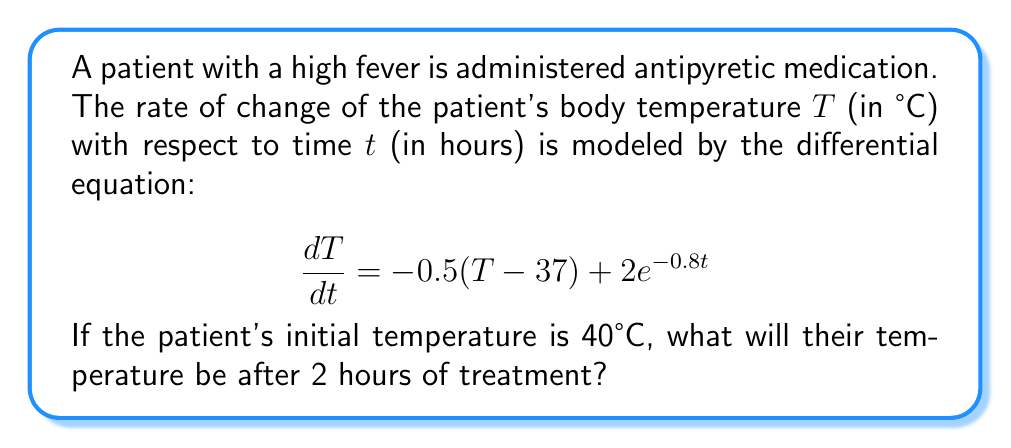Can you solve this math problem? To solve this problem, we need to use the given first-order differential equation and initial condition:

1) The differential equation is:
   $$\frac{dT}{dt} = -0.5(T - 37) + 2e^{-0.8t}$$

2) The initial condition is:
   $T(0) = 40°C$

3) This is a linear first-order differential equation. We can solve it using the integrating factor method.

4) First, rearrange the equation:
   $$\frac{dT}{dt} + 0.5T = 18.5 + 2e^{-0.8t}$$

5) The integrating factor is:
   $$\mu(t) = e^{\int 0.5 dt} = e^{0.5t}$$

6) Multiply both sides of the equation by the integrating factor:
   $$e^{0.5t}\frac{dT}{dt} + 0.5e^{0.5t}T = 18.5e^{0.5t} + 2e^{0.5t}e^{-0.8t}$$

7) The left side is now the derivative of $e^{0.5t}T$:
   $$\frac{d}{dt}(e^{0.5t}T) = 18.5e^{0.5t} + 2e^{-0.3t}$$

8) Integrate both sides:
   $$e^{0.5t}T = 37e^{0.5t} - \frac{20}{3}e^{-0.3t} + C$$

9) Solve for T:
   $$T = 37 - \frac{20}{3}e^{-0.8t} + Ce^{-0.5t}$$

10) Use the initial condition to find C:
    $$40 = 37 - \frac{20}{3} + C$$
    $$C = 3 + \frac{20}{3} = \frac{29}{3}$$

11) The final solution is:
    $$T = 37 - \frac{20}{3}e^{-0.8t} + \frac{29}{3}e^{-0.5t}$$

12) To find the temperature after 2 hours, substitute t = 2:
    $$T(2) = 37 - \frac{20}{3}e^{-1.6} + \frac{29}{3}e^{-1}$$

13) Calculate the result:
    $$T(2) \approx 37.95°C$$
Answer: After 2 hours of treatment, the patient's temperature will be approximately 37.95°C. 